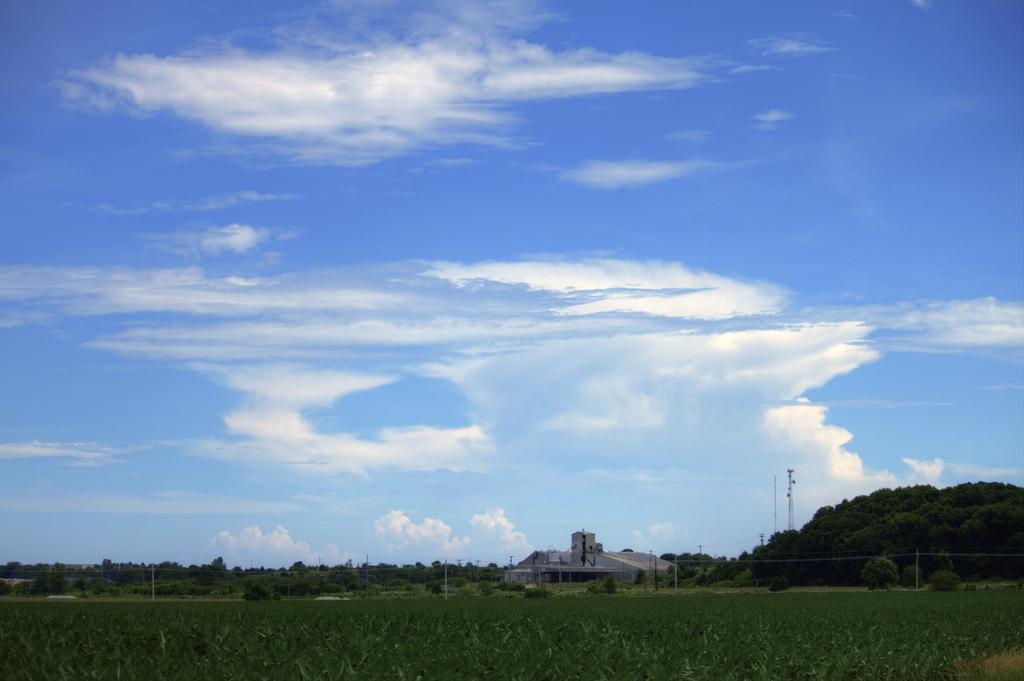Describe this image in one or two sentences. In this picture we can see few plants, poles and a building, in the background we can find few trees, towers and clouds. 